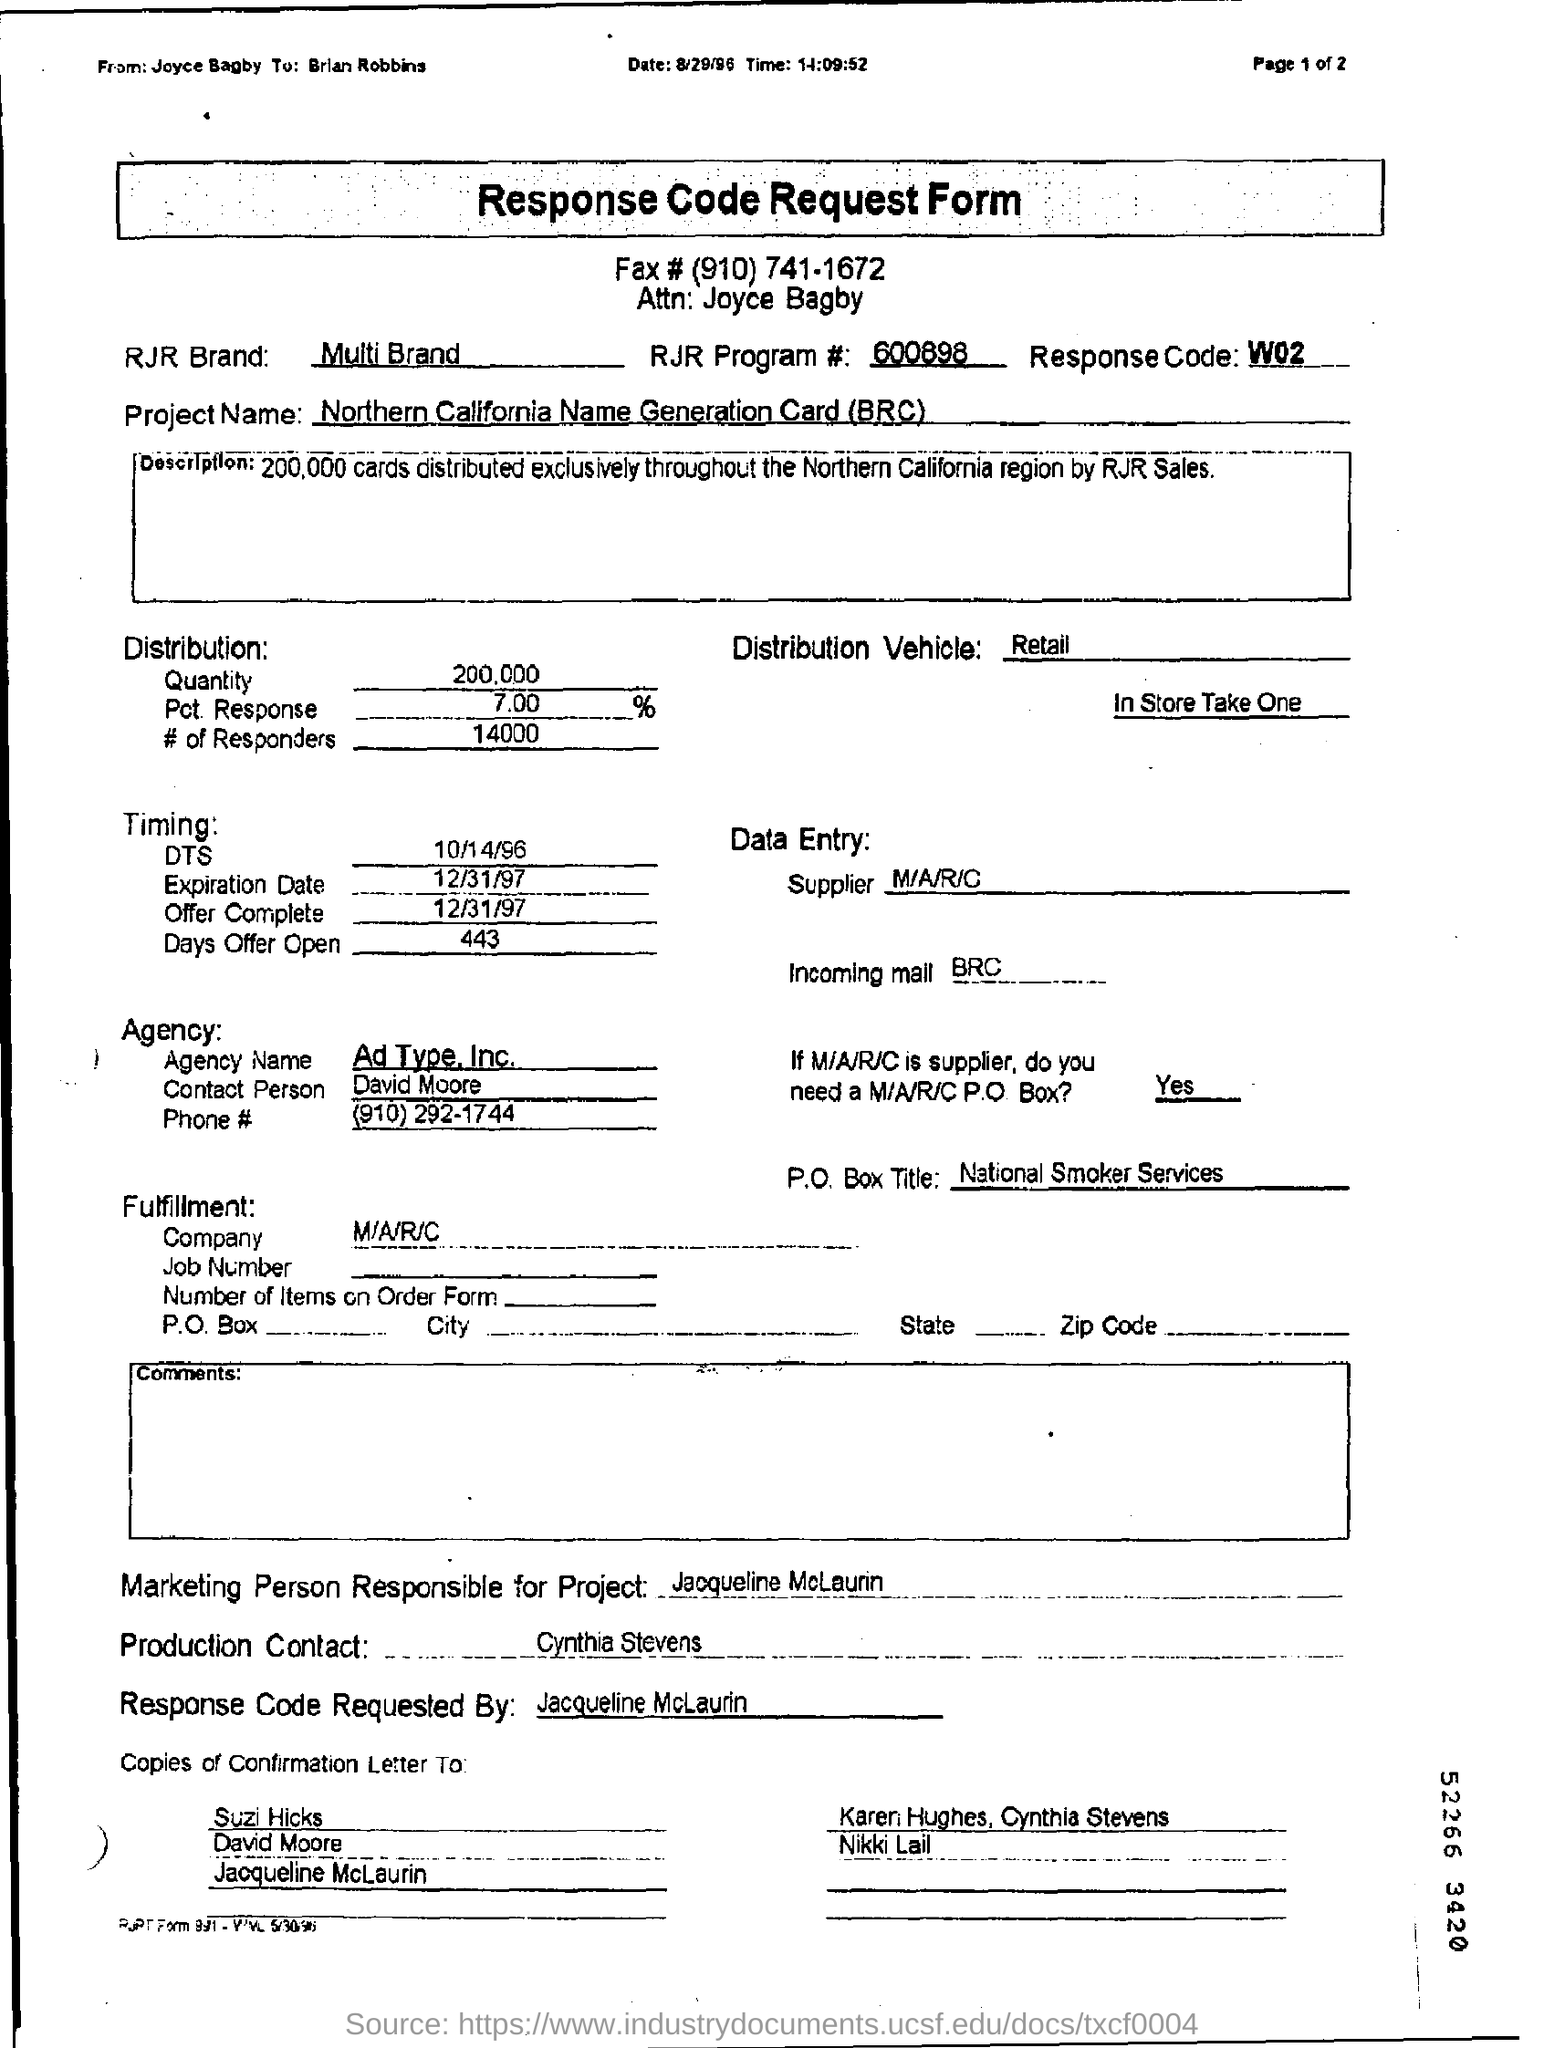Draw attention to some important aspects in this diagram. The production contact is Cynthia Stevens. The response code is W02. The RJR program number is 600898. The Northern California Name Generation Card (BRC) project is a tool used to generate unique names for various projects. In the northern California region, RJR distributed approximately 200,000 cards. 